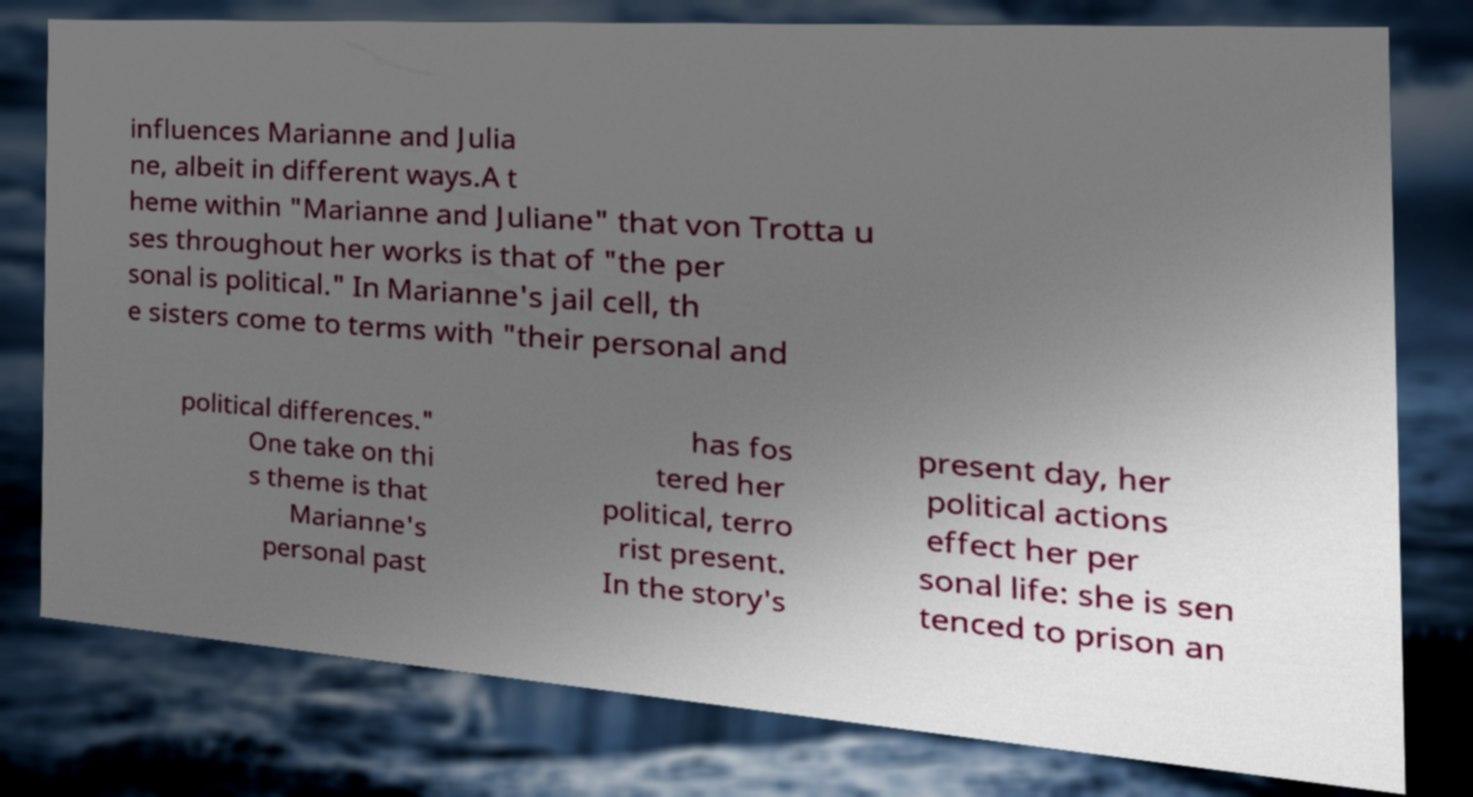Please read and relay the text visible in this image. What does it say? influences Marianne and Julia ne, albeit in different ways.A t heme within "Marianne and Juliane" that von Trotta u ses throughout her works is that of "the per sonal is political." In Marianne's jail cell, th e sisters come to terms with "their personal and political differences." One take on thi s theme is that Marianne's personal past has fos tered her political, terro rist present. In the story's present day, her political actions effect her per sonal life: she is sen tenced to prison an 